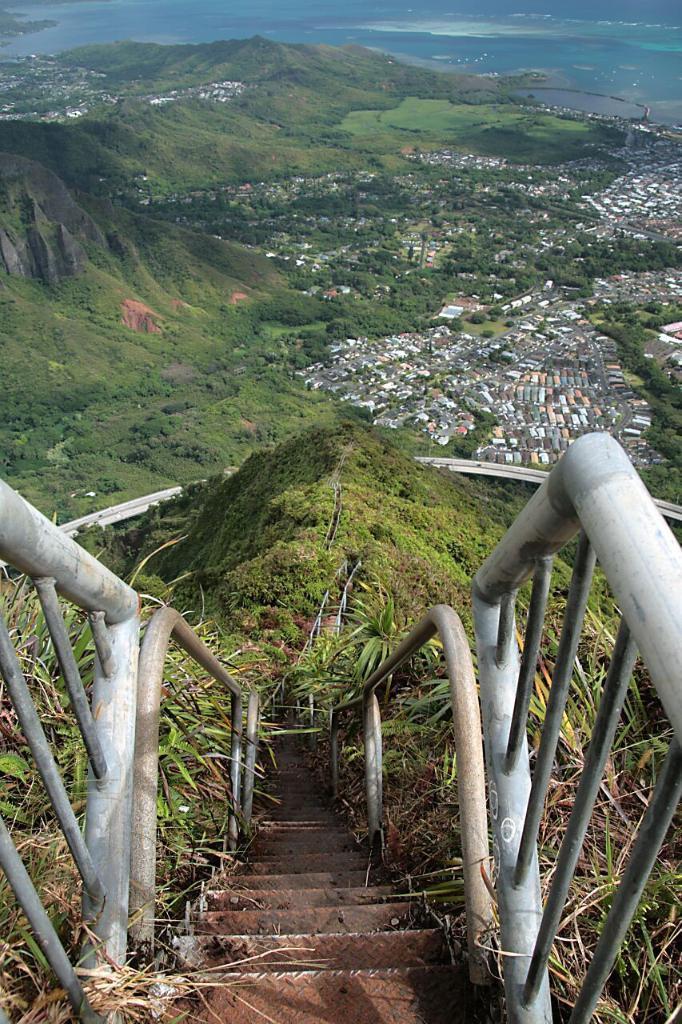Could you give a brief overview of what you see in this image? In this image, we can see few plants, rods, stairs. Background there are few mountains, sea, houses, trees we can see. 